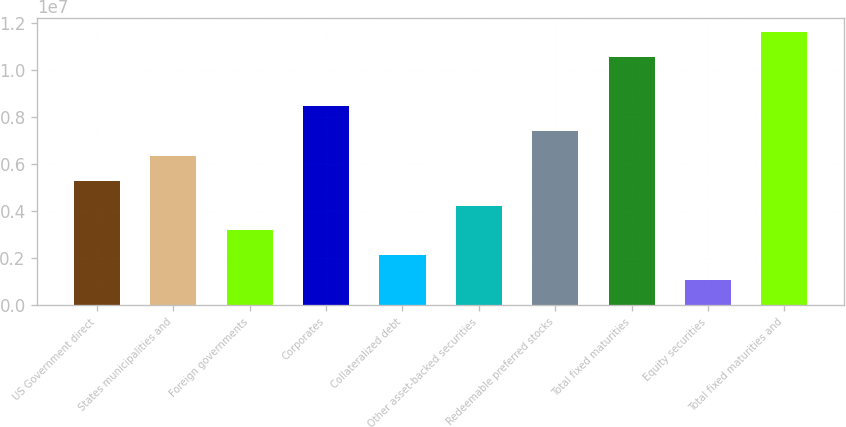Convert chart to OTSL. <chart><loc_0><loc_0><loc_500><loc_500><bar_chart><fcel>US Government direct<fcel>States municipalities and<fcel>Foreign governments<fcel>Corporates<fcel>Collateralized debt<fcel>Other asset-backed securities<fcel>Redeemable preferred stocks<fcel>Total fixed maturities<fcel>Equity securities<fcel>Total fixed maturities and<nl><fcel>5.28014e+06<fcel>6.33615e+06<fcel>3.16813e+06<fcel>8.44817e+06<fcel>2.11212e+06<fcel>4.22414e+06<fcel>7.39216e+06<fcel>1.0543e+07<fcel>1.05611e+06<fcel>1.1599e+07<nl></chart> 